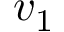Convert formula to latex. <formula><loc_0><loc_0><loc_500><loc_500>v _ { 1 }</formula> 